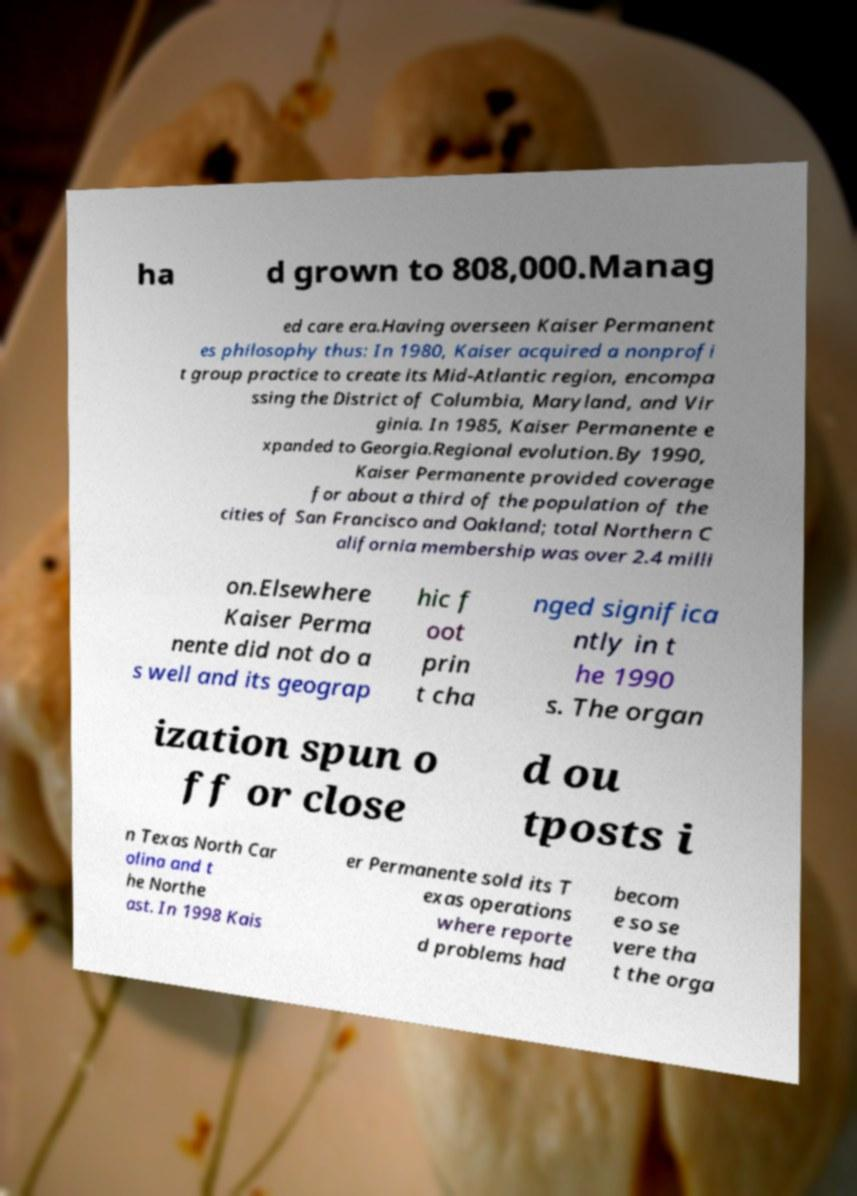What messages or text are displayed in this image? I need them in a readable, typed format. ha d grown to 808,000.Manag ed care era.Having overseen Kaiser Permanent es philosophy thus: In 1980, Kaiser acquired a nonprofi t group practice to create its Mid-Atlantic region, encompa ssing the District of Columbia, Maryland, and Vir ginia. In 1985, Kaiser Permanente e xpanded to Georgia.Regional evolution.By 1990, Kaiser Permanente provided coverage for about a third of the population of the cities of San Francisco and Oakland; total Northern C alifornia membership was over 2.4 milli on.Elsewhere Kaiser Perma nente did not do a s well and its geograp hic f oot prin t cha nged significa ntly in t he 1990 s. The organ ization spun o ff or close d ou tposts i n Texas North Car olina and t he Northe ast. In 1998 Kais er Permanente sold its T exas operations where reporte d problems had becom e so se vere tha t the orga 